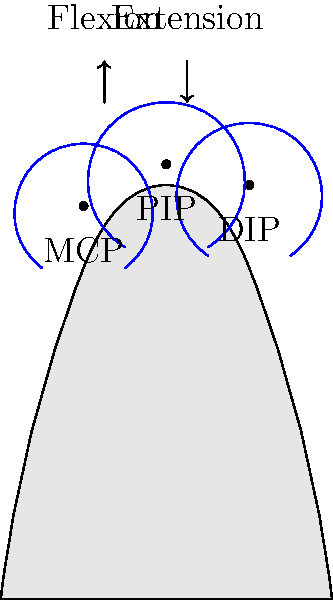In the biomechanics of finger movement, which joint in the diagram allows for the greatest range of motion during flexion and extension, and why is this important for overall hand function? To answer this question, let's examine the joints of the finger:

1. The diagram shows three main joints in a finger:
   a) Metacarpophalangeal (MCP) joint: Where the finger meets the palm
   b) Proximal Interphalangeal (PIP) joint: The middle joint of the finger
   c) Distal Interphalangeal (DIP) joint: The joint closest to the fingertip

2. Range of motion:
   a) MCP joint: Typically allows for about 90° of flexion and 30-45° of extension
   b) PIP joint: Allows for approximately 100-110° of flexion and minimal extension
   c) DIP joint: Allows for about 70-80° of flexion and minimal extension

3. The MCP joint allows for the greatest range of motion because:
   a) It can both flex and extend significantly
   b) It also allows for some abduction and adduction (side-to-side movement)

4. Importance for hand function:
   a) Greater range of motion at the MCP joint allows for more versatile finger positioning
   b) This versatility is crucial for tasks requiring precision, such as writing or manipulating small objects
   c) It also contributes to the overall gripping strength and adaptability of the hand

5. The combination of movements at all joints allows for complex hand functions:
   a) PIP and DIP joints provide additional flexion for grasping objects
   b) MCP joint's range of motion allows for positioning the fingers optimally

In conclusion, the MCP joint allows for the greatest range of motion during flexion and extension, which is vital for the hand's ability to perform a wide variety of tasks with precision and adaptability.
Answer: Metacarpophalangeal (MCP) joint; allows versatile finger positioning for precise and adaptable hand functions. 